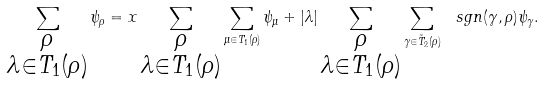<formula> <loc_0><loc_0><loc_500><loc_500>\sum _ { \substack { \rho \\ \lambda \in T _ { 1 } ( \rho ) } } \psi _ { \rho } = x \sum _ { \substack { \rho \\ \lambda \in T _ { 1 } ( \rho ) } } \sum _ { \mu \in T _ { 1 } ( \rho ) } \psi _ { \mu } + | \lambda | \sum _ { \substack { \rho \\ \lambda \in T _ { 1 } ( \rho ) } } \sum _ { \gamma \in \tilde { T } _ { 2 } ( \rho ) } \ s g n ( \gamma , \rho ) \psi _ { \gamma } .</formula> 